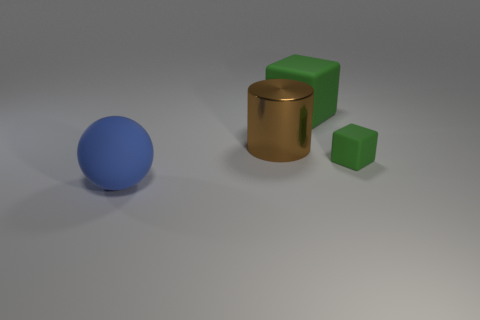How many matte objects are either yellow things or large brown cylinders? In the image, there are no matte yellow objects or large brown cylinders present, as the only objects depicted are a blue sphere, a green cube, and a smaller green cube, alongside a brown cylinder that is not large but rather medium-sized. 